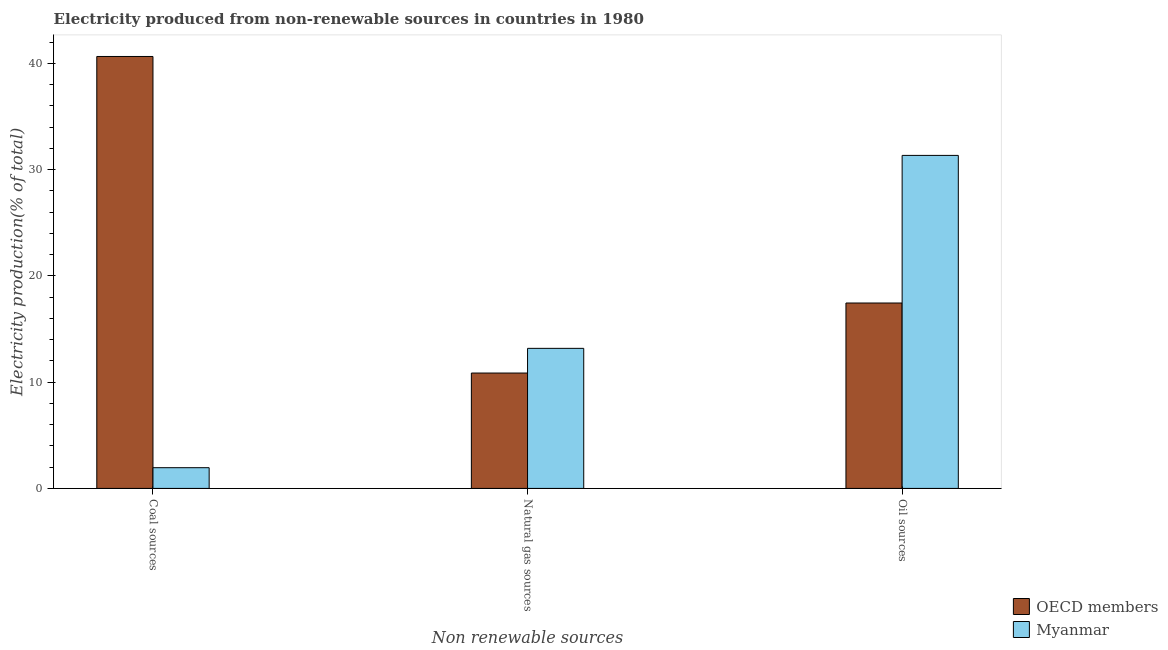How many groups of bars are there?
Keep it short and to the point. 3. Are the number of bars per tick equal to the number of legend labels?
Keep it short and to the point. Yes. Are the number of bars on each tick of the X-axis equal?
Make the answer very short. Yes. How many bars are there on the 3rd tick from the right?
Keep it short and to the point. 2. What is the label of the 3rd group of bars from the left?
Your answer should be very brief. Oil sources. What is the percentage of electricity produced by coal in Myanmar?
Your response must be concise. 1.95. Across all countries, what is the maximum percentage of electricity produced by coal?
Ensure brevity in your answer.  40.65. Across all countries, what is the minimum percentage of electricity produced by oil sources?
Your answer should be very brief. 17.45. In which country was the percentage of electricity produced by natural gas maximum?
Provide a short and direct response. Myanmar. In which country was the percentage of electricity produced by coal minimum?
Your response must be concise. Myanmar. What is the total percentage of electricity produced by natural gas in the graph?
Offer a very short reply. 24.04. What is the difference between the percentage of electricity produced by oil sources in OECD members and that in Myanmar?
Your response must be concise. -13.89. What is the difference between the percentage of electricity produced by coal in Myanmar and the percentage of electricity produced by natural gas in OECD members?
Your response must be concise. -8.91. What is the average percentage of electricity produced by coal per country?
Provide a succinct answer. 21.3. What is the difference between the percentage of electricity produced by oil sources and percentage of electricity produced by natural gas in Myanmar?
Offer a very short reply. 18.16. In how many countries, is the percentage of electricity produced by oil sources greater than 26 %?
Offer a terse response. 1. What is the ratio of the percentage of electricity produced by natural gas in OECD members to that in Myanmar?
Offer a very short reply. 0.82. Is the percentage of electricity produced by natural gas in Myanmar less than that in OECD members?
Give a very brief answer. No. Is the difference between the percentage of electricity produced by oil sources in Myanmar and OECD members greater than the difference between the percentage of electricity produced by coal in Myanmar and OECD members?
Make the answer very short. Yes. What is the difference between the highest and the second highest percentage of electricity produced by coal?
Provide a succinct answer. 38.7. What is the difference between the highest and the lowest percentage of electricity produced by natural gas?
Keep it short and to the point. 2.32. What does the 1st bar from the right in Oil sources represents?
Your answer should be very brief. Myanmar. Is it the case that in every country, the sum of the percentage of electricity produced by coal and percentage of electricity produced by natural gas is greater than the percentage of electricity produced by oil sources?
Your response must be concise. No. How many bars are there?
Make the answer very short. 6. How many countries are there in the graph?
Your answer should be very brief. 2. What is the difference between two consecutive major ticks on the Y-axis?
Ensure brevity in your answer.  10. Are the values on the major ticks of Y-axis written in scientific E-notation?
Keep it short and to the point. No. What is the title of the graph?
Provide a succinct answer. Electricity produced from non-renewable sources in countries in 1980. What is the label or title of the X-axis?
Your answer should be compact. Non renewable sources. What is the Electricity production(% of total) of OECD members in Coal sources?
Provide a succinct answer. 40.65. What is the Electricity production(% of total) in Myanmar in Coal sources?
Provide a succinct answer. 1.95. What is the Electricity production(% of total) of OECD members in Natural gas sources?
Provide a succinct answer. 10.86. What is the Electricity production(% of total) of Myanmar in Natural gas sources?
Ensure brevity in your answer.  13.18. What is the Electricity production(% of total) in OECD members in Oil sources?
Provide a short and direct response. 17.45. What is the Electricity production(% of total) in Myanmar in Oil sources?
Your answer should be compact. 31.34. Across all Non renewable sources, what is the maximum Electricity production(% of total) in OECD members?
Keep it short and to the point. 40.65. Across all Non renewable sources, what is the maximum Electricity production(% of total) in Myanmar?
Provide a short and direct response. 31.34. Across all Non renewable sources, what is the minimum Electricity production(% of total) in OECD members?
Your response must be concise. 10.86. Across all Non renewable sources, what is the minimum Electricity production(% of total) of Myanmar?
Keep it short and to the point. 1.95. What is the total Electricity production(% of total) in OECD members in the graph?
Give a very brief answer. 68.95. What is the total Electricity production(% of total) of Myanmar in the graph?
Make the answer very short. 46.47. What is the difference between the Electricity production(% of total) in OECD members in Coal sources and that in Natural gas sources?
Provide a short and direct response. 29.79. What is the difference between the Electricity production(% of total) in Myanmar in Coal sources and that in Natural gas sources?
Give a very brief answer. -11.23. What is the difference between the Electricity production(% of total) of OECD members in Coal sources and that in Oil sources?
Offer a very short reply. 23.2. What is the difference between the Electricity production(% of total) of Myanmar in Coal sources and that in Oil sources?
Your answer should be compact. -29.39. What is the difference between the Electricity production(% of total) in OECD members in Natural gas sources and that in Oil sources?
Provide a short and direct response. -6.59. What is the difference between the Electricity production(% of total) of Myanmar in Natural gas sources and that in Oil sources?
Provide a succinct answer. -18.16. What is the difference between the Electricity production(% of total) in OECD members in Coal sources and the Electricity production(% of total) in Myanmar in Natural gas sources?
Ensure brevity in your answer.  27.47. What is the difference between the Electricity production(% of total) in OECD members in Coal sources and the Electricity production(% of total) in Myanmar in Oil sources?
Ensure brevity in your answer.  9.31. What is the difference between the Electricity production(% of total) in OECD members in Natural gas sources and the Electricity production(% of total) in Myanmar in Oil sources?
Keep it short and to the point. -20.48. What is the average Electricity production(% of total) of OECD members per Non renewable sources?
Keep it short and to the point. 22.98. What is the average Electricity production(% of total) of Myanmar per Non renewable sources?
Offer a terse response. 15.49. What is the difference between the Electricity production(% of total) of OECD members and Electricity production(% of total) of Myanmar in Coal sources?
Your response must be concise. 38.7. What is the difference between the Electricity production(% of total) in OECD members and Electricity production(% of total) in Myanmar in Natural gas sources?
Give a very brief answer. -2.32. What is the difference between the Electricity production(% of total) in OECD members and Electricity production(% of total) in Myanmar in Oil sources?
Your answer should be compact. -13.89. What is the ratio of the Electricity production(% of total) of OECD members in Coal sources to that in Natural gas sources?
Provide a short and direct response. 3.74. What is the ratio of the Electricity production(% of total) of Myanmar in Coal sources to that in Natural gas sources?
Keep it short and to the point. 0.15. What is the ratio of the Electricity production(% of total) in OECD members in Coal sources to that in Oil sources?
Ensure brevity in your answer.  2.33. What is the ratio of the Electricity production(% of total) in Myanmar in Coal sources to that in Oil sources?
Provide a short and direct response. 0.06. What is the ratio of the Electricity production(% of total) in OECD members in Natural gas sources to that in Oil sources?
Provide a short and direct response. 0.62. What is the ratio of the Electricity production(% of total) of Myanmar in Natural gas sources to that in Oil sources?
Ensure brevity in your answer.  0.42. What is the difference between the highest and the second highest Electricity production(% of total) in OECD members?
Provide a short and direct response. 23.2. What is the difference between the highest and the second highest Electricity production(% of total) in Myanmar?
Your response must be concise. 18.16. What is the difference between the highest and the lowest Electricity production(% of total) in OECD members?
Give a very brief answer. 29.79. What is the difference between the highest and the lowest Electricity production(% of total) in Myanmar?
Your answer should be very brief. 29.39. 